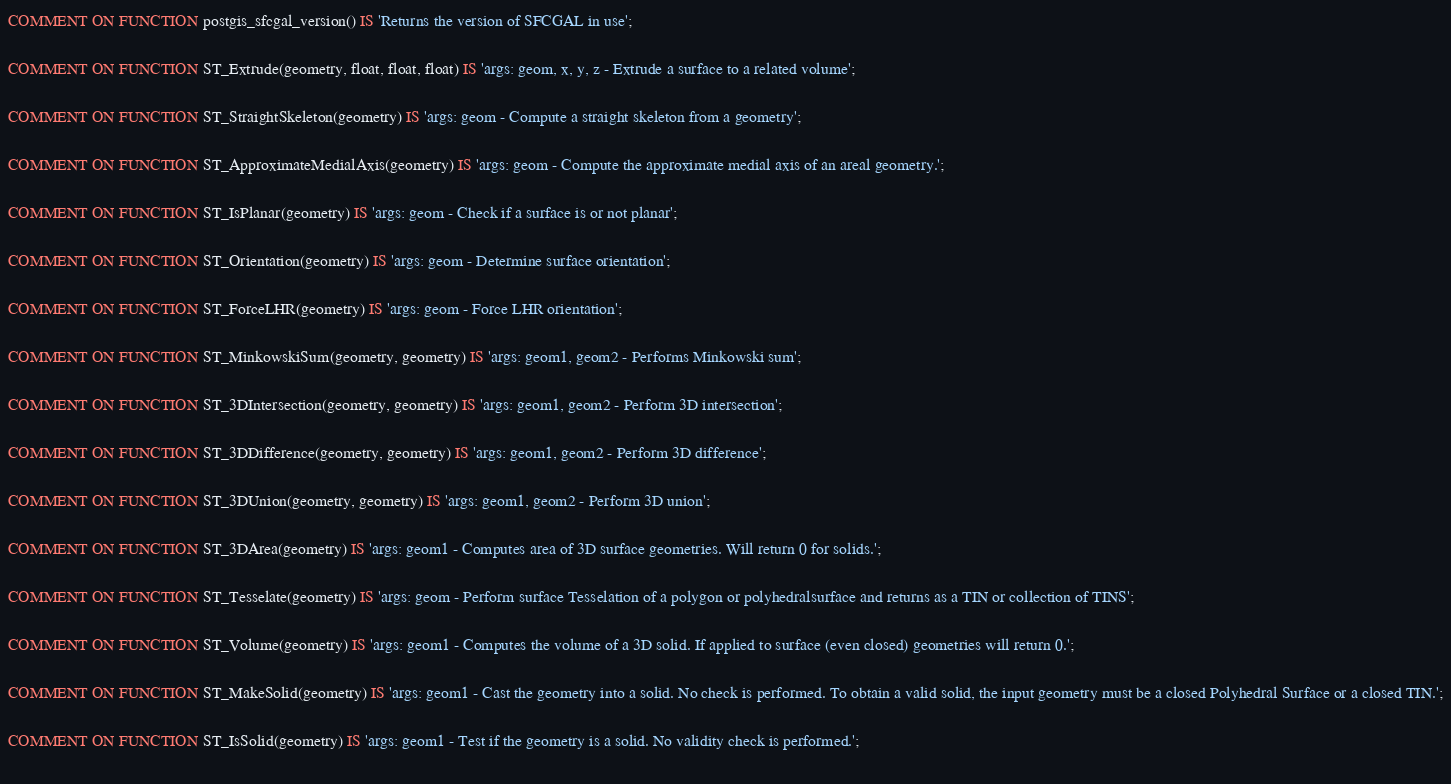<code> <loc_0><loc_0><loc_500><loc_500><_SQL_>
COMMENT ON FUNCTION postgis_sfcgal_version() IS 'Returns the version of SFCGAL in use';
			
COMMENT ON FUNCTION ST_Extrude(geometry, float, float, float) IS 'args: geom, x, y, z - Extrude a surface to a related volume';
			
COMMENT ON FUNCTION ST_StraightSkeleton(geometry) IS 'args: geom - Compute a straight skeleton from a geometry';
			
COMMENT ON FUNCTION ST_ApproximateMedialAxis(geometry) IS 'args: geom - Compute the approximate medial axis of an areal geometry.';
			
COMMENT ON FUNCTION ST_IsPlanar(geometry) IS 'args: geom - Check if a surface is or not planar';
			
COMMENT ON FUNCTION ST_Orientation(geometry) IS 'args: geom - Determine surface orientation';
			
COMMENT ON FUNCTION ST_ForceLHR(geometry) IS 'args: geom - Force LHR orientation';
			
COMMENT ON FUNCTION ST_MinkowskiSum(geometry, geometry) IS 'args: geom1, geom2 - Performs Minkowski sum';
			
COMMENT ON FUNCTION ST_3DIntersection(geometry, geometry) IS 'args: geom1, geom2 - Perform 3D intersection';
			
COMMENT ON FUNCTION ST_3DDifference(geometry, geometry) IS 'args: geom1, geom2 - Perform 3D difference';
			
COMMENT ON FUNCTION ST_3DUnion(geometry, geometry) IS 'args: geom1, geom2 - Perform 3D union';
			
COMMENT ON FUNCTION ST_3DArea(geometry) IS 'args: geom1 - Computes area of 3D surface geometries. Will return 0 for solids.';
			
COMMENT ON FUNCTION ST_Tesselate(geometry) IS 'args: geom - Perform surface Tesselation of a polygon or polyhedralsurface and returns as a TIN or collection of TINS';
			
COMMENT ON FUNCTION ST_Volume(geometry) IS 'args: geom1 - Computes the volume of a 3D solid. If applied to surface (even closed) geometries will return 0.';
			
COMMENT ON FUNCTION ST_MakeSolid(geometry) IS 'args: geom1 - Cast the geometry into a solid. No check is performed. To obtain a valid solid, the input geometry must be a closed Polyhedral Surface or a closed TIN.';
			
COMMENT ON FUNCTION ST_IsSolid(geometry) IS 'args: geom1 - Test if the geometry is a solid. No validity check is performed.';
			</code> 